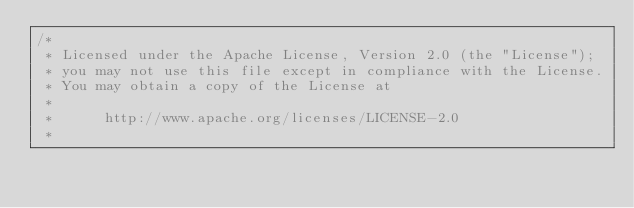<code> <loc_0><loc_0><loc_500><loc_500><_Java_>/*
 * Licensed under the Apache License, Version 2.0 (the "License");
 * you may not use this file except in compliance with the License.
 * You may obtain a copy of the License at
 *
 *      http://www.apache.org/licenses/LICENSE-2.0
 *</code> 